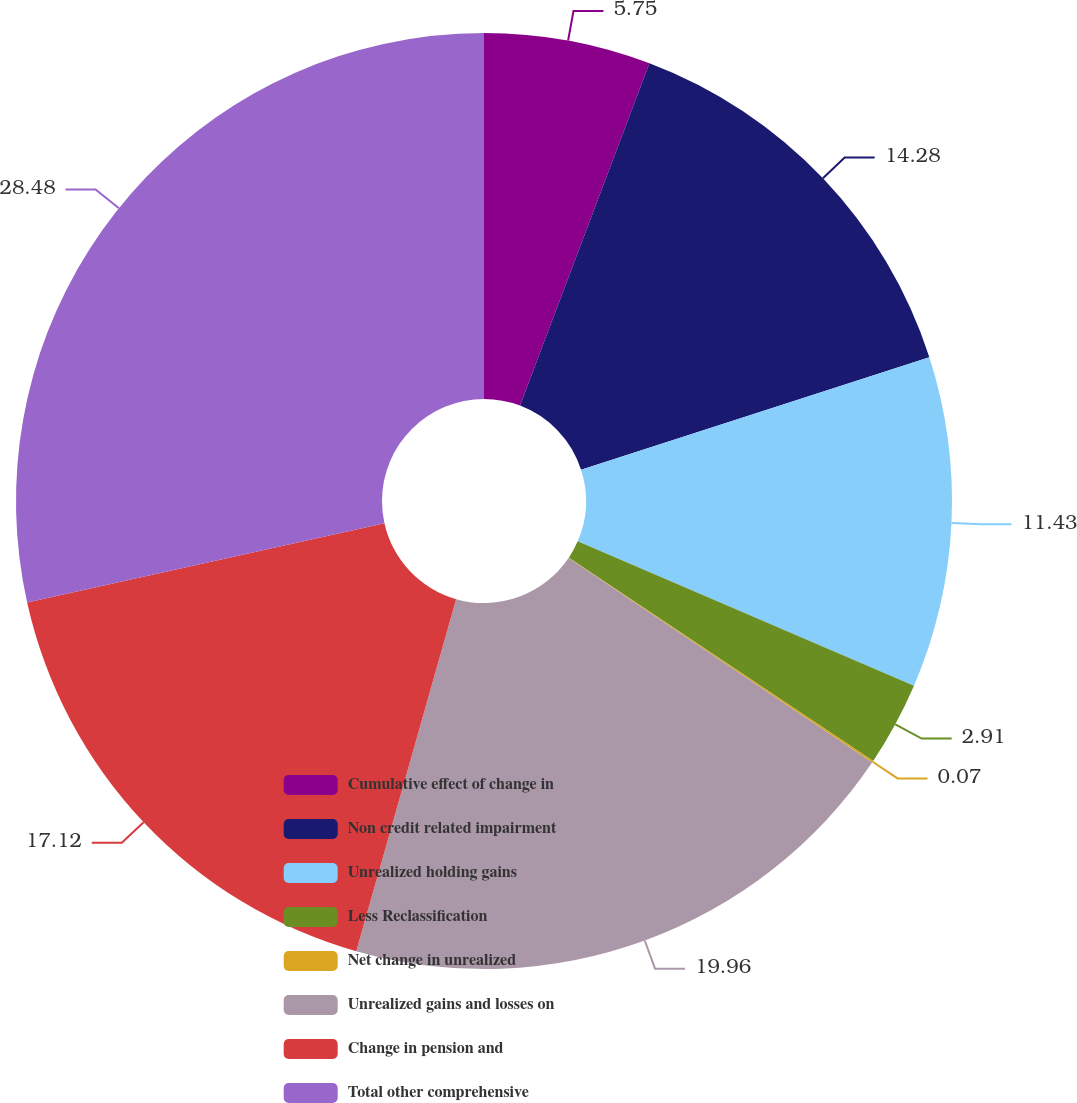<chart> <loc_0><loc_0><loc_500><loc_500><pie_chart><fcel>Cumulative effect of change in<fcel>Non credit related impairment<fcel>Unrealized holding gains<fcel>Less Reclassification<fcel>Net change in unrealized<fcel>Unrealized gains and losses on<fcel>Change in pension and<fcel>Total other comprehensive<nl><fcel>5.75%<fcel>14.28%<fcel>11.43%<fcel>2.91%<fcel>0.07%<fcel>19.96%<fcel>17.12%<fcel>28.48%<nl></chart> 